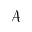<formula> <loc_0><loc_0><loc_500><loc_500>\mathcal { A }</formula> 